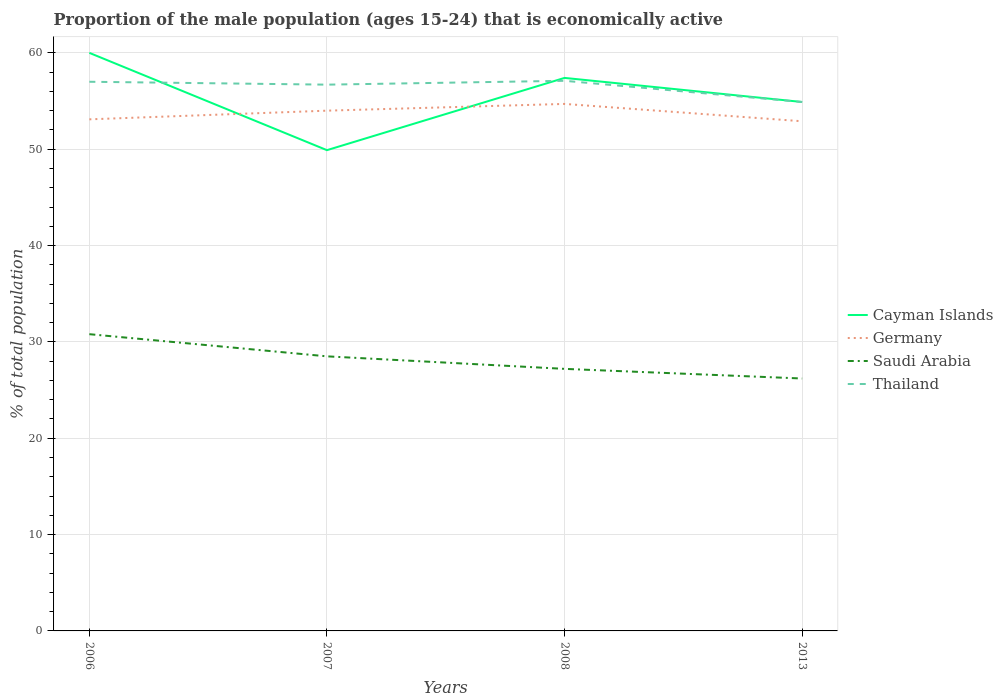How many different coloured lines are there?
Provide a short and direct response. 4. Is the number of lines equal to the number of legend labels?
Your answer should be very brief. Yes. Across all years, what is the maximum proportion of the male population that is economically active in Germany?
Provide a succinct answer. 52.9. In which year was the proportion of the male population that is economically active in Cayman Islands maximum?
Your response must be concise. 2007. What is the difference between the highest and the second highest proportion of the male population that is economically active in Germany?
Offer a very short reply. 1.8. Is the proportion of the male population that is economically active in Germany strictly greater than the proportion of the male population that is economically active in Cayman Islands over the years?
Your response must be concise. No. How many lines are there?
Your answer should be very brief. 4. Are the values on the major ticks of Y-axis written in scientific E-notation?
Your answer should be compact. No. Where does the legend appear in the graph?
Your answer should be very brief. Center right. How many legend labels are there?
Your answer should be compact. 4. What is the title of the graph?
Your response must be concise. Proportion of the male population (ages 15-24) that is economically active. Does "Caribbean small states" appear as one of the legend labels in the graph?
Offer a very short reply. No. What is the label or title of the X-axis?
Provide a short and direct response. Years. What is the label or title of the Y-axis?
Your response must be concise. % of total population. What is the % of total population in Cayman Islands in 2006?
Provide a short and direct response. 60. What is the % of total population of Germany in 2006?
Make the answer very short. 53.1. What is the % of total population of Saudi Arabia in 2006?
Make the answer very short. 30.8. What is the % of total population in Cayman Islands in 2007?
Make the answer very short. 49.9. What is the % of total population of Thailand in 2007?
Your answer should be very brief. 56.7. What is the % of total population of Cayman Islands in 2008?
Your answer should be very brief. 57.4. What is the % of total population of Germany in 2008?
Your answer should be compact. 54.7. What is the % of total population in Saudi Arabia in 2008?
Your answer should be compact. 27.2. What is the % of total population of Thailand in 2008?
Give a very brief answer. 57.1. What is the % of total population in Cayman Islands in 2013?
Offer a terse response. 54.9. What is the % of total population in Germany in 2013?
Make the answer very short. 52.9. What is the % of total population of Saudi Arabia in 2013?
Make the answer very short. 26.2. What is the % of total population of Thailand in 2013?
Give a very brief answer. 54.9. Across all years, what is the maximum % of total population of Germany?
Provide a succinct answer. 54.7. Across all years, what is the maximum % of total population in Saudi Arabia?
Your response must be concise. 30.8. Across all years, what is the maximum % of total population in Thailand?
Your response must be concise. 57.1. Across all years, what is the minimum % of total population of Cayman Islands?
Offer a very short reply. 49.9. Across all years, what is the minimum % of total population in Germany?
Your response must be concise. 52.9. Across all years, what is the minimum % of total population of Saudi Arabia?
Offer a terse response. 26.2. Across all years, what is the minimum % of total population in Thailand?
Offer a terse response. 54.9. What is the total % of total population in Cayman Islands in the graph?
Provide a short and direct response. 222.2. What is the total % of total population in Germany in the graph?
Your answer should be very brief. 214.7. What is the total % of total population of Saudi Arabia in the graph?
Your answer should be compact. 112.7. What is the total % of total population of Thailand in the graph?
Offer a terse response. 225.7. What is the difference between the % of total population in Thailand in 2006 and that in 2007?
Offer a very short reply. 0.3. What is the difference between the % of total population in Cayman Islands in 2006 and that in 2008?
Provide a succinct answer. 2.6. What is the difference between the % of total population in Saudi Arabia in 2006 and that in 2008?
Offer a very short reply. 3.6. What is the difference between the % of total population in Thailand in 2006 and that in 2008?
Provide a succinct answer. -0.1. What is the difference between the % of total population in Saudi Arabia in 2006 and that in 2013?
Provide a succinct answer. 4.6. What is the difference between the % of total population in Saudi Arabia in 2007 and that in 2008?
Provide a short and direct response. 1.3. What is the difference between the % of total population in Germany in 2007 and that in 2013?
Keep it short and to the point. 1.1. What is the difference between the % of total population in Saudi Arabia in 2007 and that in 2013?
Provide a succinct answer. 2.3. What is the difference between the % of total population in Thailand in 2007 and that in 2013?
Your answer should be compact. 1.8. What is the difference between the % of total population in Germany in 2008 and that in 2013?
Provide a short and direct response. 1.8. What is the difference between the % of total population of Saudi Arabia in 2008 and that in 2013?
Your answer should be compact. 1. What is the difference between the % of total population in Cayman Islands in 2006 and the % of total population in Germany in 2007?
Your answer should be very brief. 6. What is the difference between the % of total population of Cayman Islands in 2006 and the % of total population of Saudi Arabia in 2007?
Your response must be concise. 31.5. What is the difference between the % of total population of Cayman Islands in 2006 and the % of total population of Thailand in 2007?
Keep it short and to the point. 3.3. What is the difference between the % of total population of Germany in 2006 and the % of total population of Saudi Arabia in 2007?
Provide a succinct answer. 24.6. What is the difference between the % of total population of Saudi Arabia in 2006 and the % of total population of Thailand in 2007?
Provide a short and direct response. -25.9. What is the difference between the % of total population of Cayman Islands in 2006 and the % of total population of Germany in 2008?
Provide a succinct answer. 5.3. What is the difference between the % of total population of Cayman Islands in 2006 and the % of total population of Saudi Arabia in 2008?
Provide a succinct answer. 32.8. What is the difference between the % of total population of Germany in 2006 and the % of total population of Saudi Arabia in 2008?
Your answer should be very brief. 25.9. What is the difference between the % of total population in Saudi Arabia in 2006 and the % of total population in Thailand in 2008?
Offer a very short reply. -26.3. What is the difference between the % of total population in Cayman Islands in 2006 and the % of total population in Saudi Arabia in 2013?
Your answer should be compact. 33.8. What is the difference between the % of total population in Cayman Islands in 2006 and the % of total population in Thailand in 2013?
Ensure brevity in your answer.  5.1. What is the difference between the % of total population in Germany in 2006 and the % of total population in Saudi Arabia in 2013?
Give a very brief answer. 26.9. What is the difference between the % of total population in Germany in 2006 and the % of total population in Thailand in 2013?
Provide a short and direct response. -1.8. What is the difference between the % of total population of Saudi Arabia in 2006 and the % of total population of Thailand in 2013?
Provide a short and direct response. -24.1. What is the difference between the % of total population of Cayman Islands in 2007 and the % of total population of Germany in 2008?
Provide a succinct answer. -4.8. What is the difference between the % of total population in Cayman Islands in 2007 and the % of total population in Saudi Arabia in 2008?
Your answer should be very brief. 22.7. What is the difference between the % of total population of Cayman Islands in 2007 and the % of total population of Thailand in 2008?
Provide a succinct answer. -7.2. What is the difference between the % of total population in Germany in 2007 and the % of total population in Saudi Arabia in 2008?
Provide a short and direct response. 26.8. What is the difference between the % of total population in Germany in 2007 and the % of total population in Thailand in 2008?
Your answer should be very brief. -3.1. What is the difference between the % of total population in Saudi Arabia in 2007 and the % of total population in Thailand in 2008?
Your response must be concise. -28.6. What is the difference between the % of total population of Cayman Islands in 2007 and the % of total population of Germany in 2013?
Give a very brief answer. -3. What is the difference between the % of total population in Cayman Islands in 2007 and the % of total population in Saudi Arabia in 2013?
Give a very brief answer. 23.7. What is the difference between the % of total population in Germany in 2007 and the % of total population in Saudi Arabia in 2013?
Offer a terse response. 27.8. What is the difference between the % of total population in Germany in 2007 and the % of total population in Thailand in 2013?
Give a very brief answer. -0.9. What is the difference between the % of total population of Saudi Arabia in 2007 and the % of total population of Thailand in 2013?
Your answer should be compact. -26.4. What is the difference between the % of total population in Cayman Islands in 2008 and the % of total population in Germany in 2013?
Provide a succinct answer. 4.5. What is the difference between the % of total population of Cayman Islands in 2008 and the % of total population of Saudi Arabia in 2013?
Make the answer very short. 31.2. What is the difference between the % of total population of Cayman Islands in 2008 and the % of total population of Thailand in 2013?
Your answer should be very brief. 2.5. What is the difference between the % of total population of Germany in 2008 and the % of total population of Saudi Arabia in 2013?
Provide a succinct answer. 28.5. What is the difference between the % of total population in Saudi Arabia in 2008 and the % of total population in Thailand in 2013?
Provide a short and direct response. -27.7. What is the average % of total population in Cayman Islands per year?
Give a very brief answer. 55.55. What is the average % of total population in Germany per year?
Give a very brief answer. 53.67. What is the average % of total population in Saudi Arabia per year?
Your answer should be compact. 28.18. What is the average % of total population in Thailand per year?
Ensure brevity in your answer.  56.42. In the year 2006, what is the difference between the % of total population in Cayman Islands and % of total population in Germany?
Offer a very short reply. 6.9. In the year 2006, what is the difference between the % of total population of Cayman Islands and % of total population of Saudi Arabia?
Your answer should be very brief. 29.2. In the year 2006, what is the difference between the % of total population in Germany and % of total population in Saudi Arabia?
Ensure brevity in your answer.  22.3. In the year 2006, what is the difference between the % of total population in Germany and % of total population in Thailand?
Your response must be concise. -3.9. In the year 2006, what is the difference between the % of total population in Saudi Arabia and % of total population in Thailand?
Make the answer very short. -26.2. In the year 2007, what is the difference between the % of total population in Cayman Islands and % of total population in Germany?
Ensure brevity in your answer.  -4.1. In the year 2007, what is the difference between the % of total population of Cayman Islands and % of total population of Saudi Arabia?
Provide a short and direct response. 21.4. In the year 2007, what is the difference between the % of total population in Cayman Islands and % of total population in Thailand?
Make the answer very short. -6.8. In the year 2007, what is the difference between the % of total population of Germany and % of total population of Saudi Arabia?
Give a very brief answer. 25.5. In the year 2007, what is the difference between the % of total population of Saudi Arabia and % of total population of Thailand?
Offer a very short reply. -28.2. In the year 2008, what is the difference between the % of total population of Cayman Islands and % of total population of Germany?
Give a very brief answer. 2.7. In the year 2008, what is the difference between the % of total population in Cayman Islands and % of total population in Saudi Arabia?
Ensure brevity in your answer.  30.2. In the year 2008, what is the difference between the % of total population of Cayman Islands and % of total population of Thailand?
Your answer should be very brief. 0.3. In the year 2008, what is the difference between the % of total population of Germany and % of total population of Saudi Arabia?
Offer a terse response. 27.5. In the year 2008, what is the difference between the % of total population in Saudi Arabia and % of total population in Thailand?
Your answer should be very brief. -29.9. In the year 2013, what is the difference between the % of total population of Cayman Islands and % of total population of Saudi Arabia?
Your answer should be compact. 28.7. In the year 2013, what is the difference between the % of total population of Cayman Islands and % of total population of Thailand?
Your answer should be very brief. 0. In the year 2013, what is the difference between the % of total population in Germany and % of total population in Saudi Arabia?
Ensure brevity in your answer.  26.7. In the year 2013, what is the difference between the % of total population in Saudi Arabia and % of total population in Thailand?
Keep it short and to the point. -28.7. What is the ratio of the % of total population in Cayman Islands in 2006 to that in 2007?
Ensure brevity in your answer.  1.2. What is the ratio of the % of total population of Germany in 2006 to that in 2007?
Give a very brief answer. 0.98. What is the ratio of the % of total population of Saudi Arabia in 2006 to that in 2007?
Your answer should be very brief. 1.08. What is the ratio of the % of total population of Thailand in 2006 to that in 2007?
Your answer should be compact. 1.01. What is the ratio of the % of total population of Cayman Islands in 2006 to that in 2008?
Your response must be concise. 1.05. What is the ratio of the % of total population of Germany in 2006 to that in 2008?
Your answer should be very brief. 0.97. What is the ratio of the % of total population in Saudi Arabia in 2006 to that in 2008?
Give a very brief answer. 1.13. What is the ratio of the % of total population in Cayman Islands in 2006 to that in 2013?
Offer a very short reply. 1.09. What is the ratio of the % of total population of Saudi Arabia in 2006 to that in 2013?
Ensure brevity in your answer.  1.18. What is the ratio of the % of total population in Thailand in 2006 to that in 2013?
Give a very brief answer. 1.04. What is the ratio of the % of total population in Cayman Islands in 2007 to that in 2008?
Keep it short and to the point. 0.87. What is the ratio of the % of total population in Germany in 2007 to that in 2008?
Give a very brief answer. 0.99. What is the ratio of the % of total population of Saudi Arabia in 2007 to that in 2008?
Keep it short and to the point. 1.05. What is the ratio of the % of total population in Cayman Islands in 2007 to that in 2013?
Offer a terse response. 0.91. What is the ratio of the % of total population in Germany in 2007 to that in 2013?
Offer a very short reply. 1.02. What is the ratio of the % of total population of Saudi Arabia in 2007 to that in 2013?
Keep it short and to the point. 1.09. What is the ratio of the % of total population of Thailand in 2007 to that in 2013?
Your response must be concise. 1.03. What is the ratio of the % of total population of Cayman Islands in 2008 to that in 2013?
Keep it short and to the point. 1.05. What is the ratio of the % of total population in Germany in 2008 to that in 2013?
Your response must be concise. 1.03. What is the ratio of the % of total population of Saudi Arabia in 2008 to that in 2013?
Provide a succinct answer. 1.04. What is the ratio of the % of total population of Thailand in 2008 to that in 2013?
Provide a succinct answer. 1.04. What is the difference between the highest and the second highest % of total population of Cayman Islands?
Your response must be concise. 2.6. What is the difference between the highest and the second highest % of total population of Saudi Arabia?
Your response must be concise. 2.3. What is the difference between the highest and the lowest % of total population of Germany?
Make the answer very short. 1.8. What is the difference between the highest and the lowest % of total population of Saudi Arabia?
Offer a terse response. 4.6. What is the difference between the highest and the lowest % of total population in Thailand?
Make the answer very short. 2.2. 